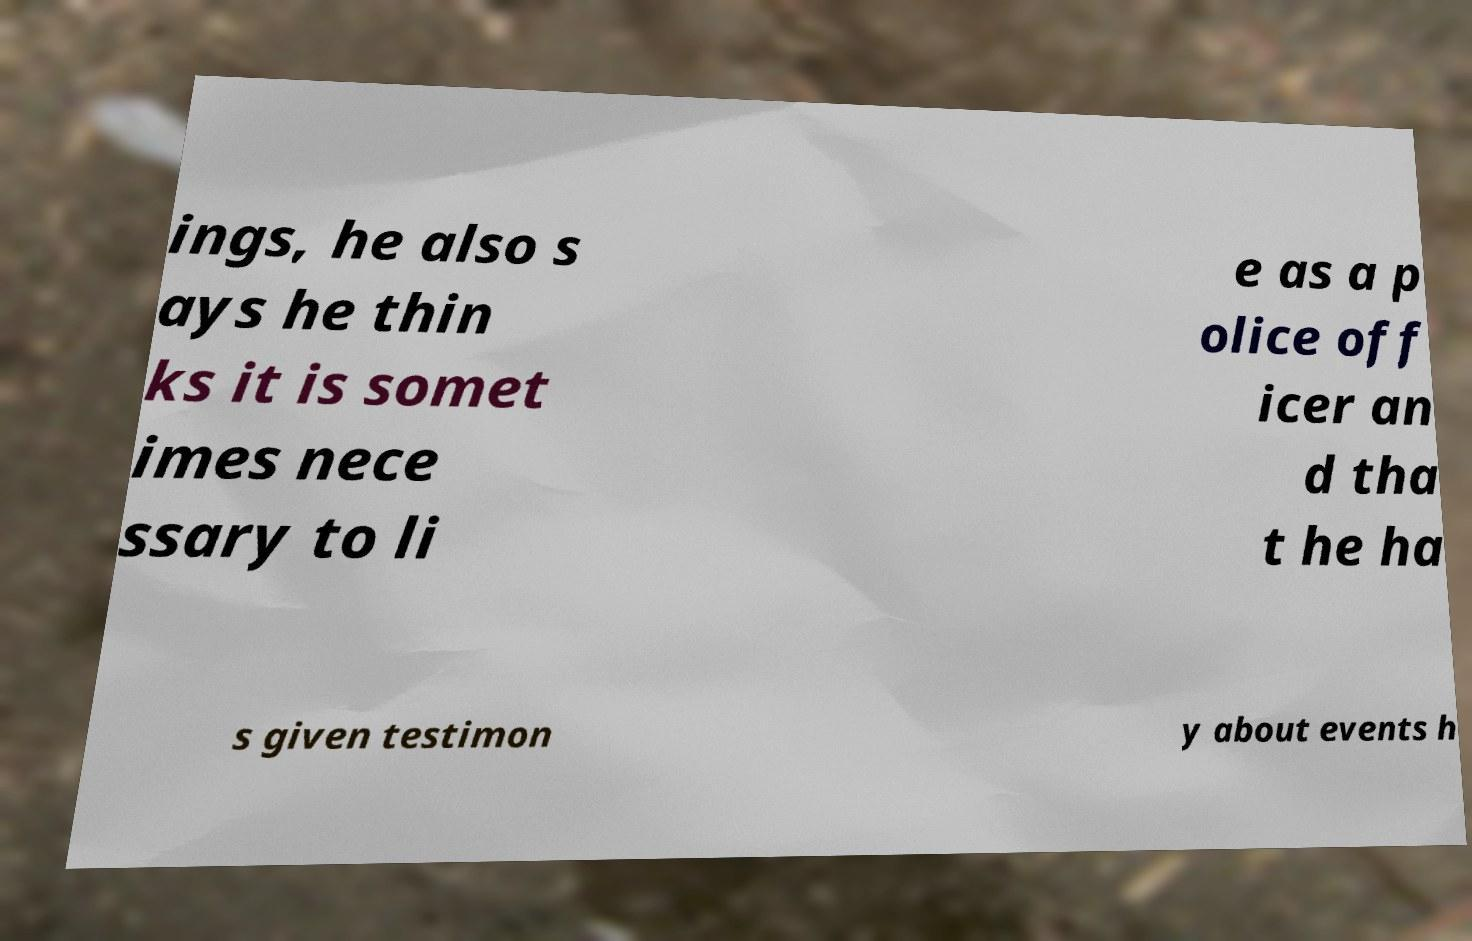Could you extract and type out the text from this image? ings, he also s ays he thin ks it is somet imes nece ssary to li e as a p olice off icer an d tha t he ha s given testimon y about events h 